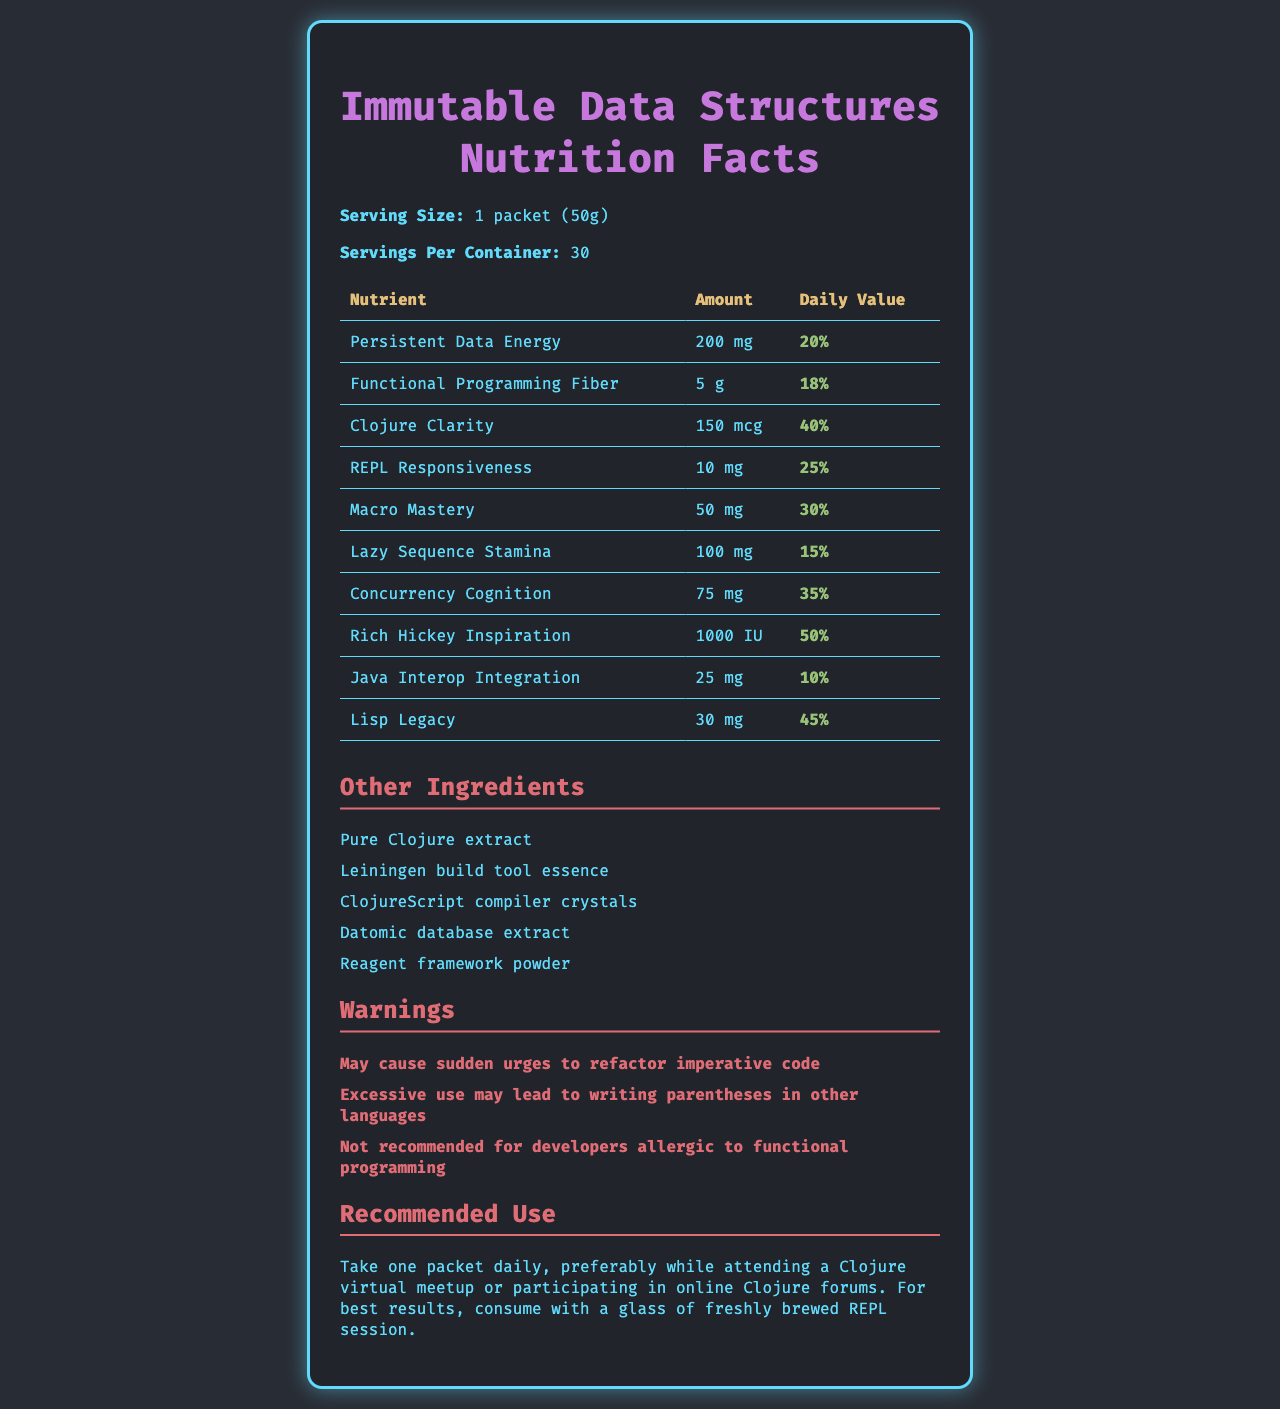what is the serving size? The serving size is stated directly below the title "Immutable Data Structures Nutrition Facts".
Answer: 1 packet (50g) how many servings are there per container? The number of servings per container is indicated under "Servings Per Container".
Answer: 30 how much Persistent Data Energy is in each serving? This information is listed under the "Nutrients" section, where it states the amount of Persistent Data Energy per serving.
Answer: 200 mg what is the daily value percentage for Clojure Clarity? The daily value percentage for Clojure Clarity is shown in the "Nutrients" section of the table.
Answer: 40% which nutrient has the highest daily value percentage? Rich Hickey Inspiration has a daily value of 50%, which is the highest among the listed nutrients.
Answer: Rich Hickey Inspiration what are the other ingredients in this vitamin supplement? These ingredients are listed under the "Other Ingredients" section.
Answer: Pure Clojure extract, Leiningen build tool essence, ClojureScript compiler crystals, Datomic database extract, Reagent framework powder what is the recommended use for this supplement? The recommended use is stated clearly in the "Recommended Use" section at the end of the document.
Answer: Take one packet daily, preferably while attending a Clojure virtual meetup or participating in online Clojure forums. For best results, consume with a glass of freshly brewed REPL session. what warning is given about excessive use of this supplement? This warning is listed in the "Warnings" section.
Answer: Excessive use may lead to writing parentheses in other languages identify a nutrient that contributes to functional programming. A. Persistent Data Energy B. Functional Programming Fiber C. Lazy Sequence Stamina D. Lisp Legacy The name "Functional Programming Fiber" suggests its contribution to functional programming.
Answer: B. Functional Programming Fiber what is the daily value percentage of Lazy Sequence Stamina? A. 15% B. 20% C. 25% D. 30% The daily value percentage of Lazy Sequence Stamina is listed as 15% in the "Nutrients" section.
Answer: A. 15% is the use of this supplement recommended for developers allergic to functional programming? A warning explicitly states that it is not recommended for developers allergic to functional programming.
Answer: No summarize the main idea of the document. The document mimics a nutrition label but uses specific terms related to Clojure and functional programming to humorously present its information.
Answer: The document provides a nutrition facts label for an "Immutable Data Structures" vitamin supplement pack designed to support software developers, especially those working with Clojure. It lists the serving size, number of servings per container, and the amounts and daily values of various fictional nutrients. Other ingredients are listed, along with warnings and recommended use instructions. can you determine the exact manufacturer of this supplement? The document doesn't provide any details about the manufacturer.
Answer: Not enough information 